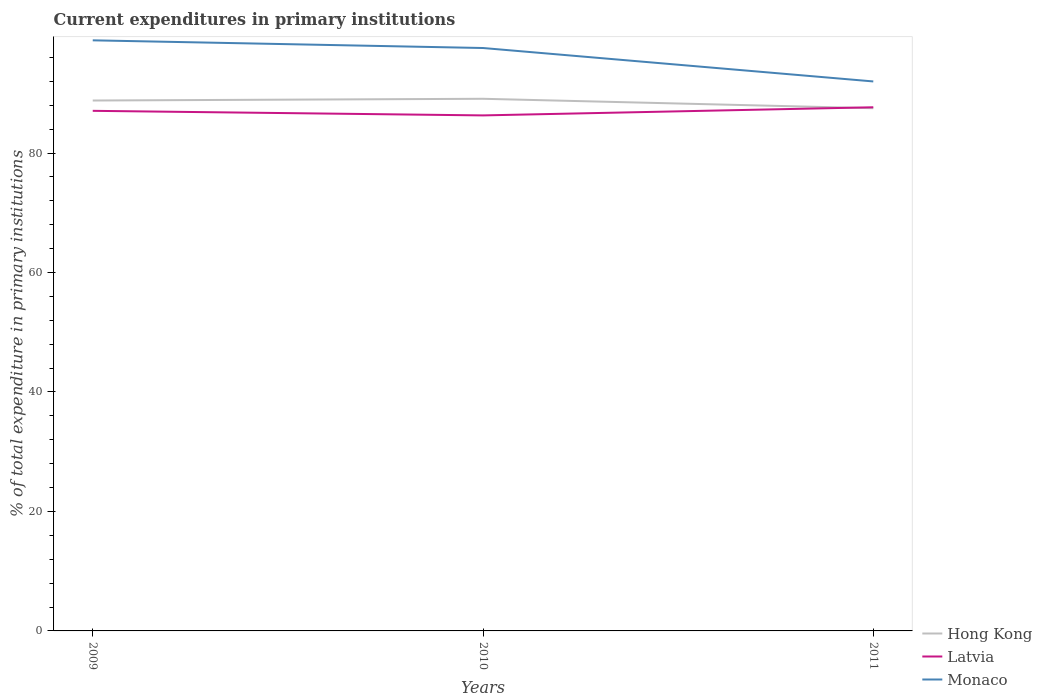How many different coloured lines are there?
Your answer should be compact. 3. Does the line corresponding to Monaco intersect with the line corresponding to Hong Kong?
Provide a short and direct response. No. Across all years, what is the maximum current expenditures in primary institutions in Latvia?
Make the answer very short. 86.3. What is the total current expenditures in primary institutions in Monaco in the graph?
Provide a succinct answer. 5.6. What is the difference between the highest and the second highest current expenditures in primary institutions in Hong Kong?
Ensure brevity in your answer.  1.58. Is the current expenditures in primary institutions in Hong Kong strictly greater than the current expenditures in primary institutions in Latvia over the years?
Make the answer very short. No. How many years are there in the graph?
Provide a short and direct response. 3. What is the difference between two consecutive major ticks on the Y-axis?
Give a very brief answer. 20. Are the values on the major ticks of Y-axis written in scientific E-notation?
Your response must be concise. No. Does the graph contain any zero values?
Make the answer very short. No. Does the graph contain grids?
Keep it short and to the point. No. How are the legend labels stacked?
Keep it short and to the point. Vertical. What is the title of the graph?
Ensure brevity in your answer.  Current expenditures in primary institutions. What is the label or title of the Y-axis?
Provide a succinct answer. % of total expenditure in primary institutions. What is the % of total expenditure in primary institutions of Hong Kong in 2009?
Offer a very short reply. 88.79. What is the % of total expenditure in primary institutions in Latvia in 2009?
Your response must be concise. 87.06. What is the % of total expenditure in primary institutions in Monaco in 2009?
Provide a short and direct response. 98.87. What is the % of total expenditure in primary institutions in Hong Kong in 2010?
Offer a terse response. 89.08. What is the % of total expenditure in primary institutions of Latvia in 2010?
Ensure brevity in your answer.  86.3. What is the % of total expenditure in primary institutions of Monaco in 2010?
Offer a very short reply. 97.58. What is the % of total expenditure in primary institutions in Hong Kong in 2011?
Ensure brevity in your answer.  87.5. What is the % of total expenditure in primary institutions of Latvia in 2011?
Your answer should be very brief. 87.66. What is the % of total expenditure in primary institutions of Monaco in 2011?
Ensure brevity in your answer.  91.98. Across all years, what is the maximum % of total expenditure in primary institutions in Hong Kong?
Offer a terse response. 89.08. Across all years, what is the maximum % of total expenditure in primary institutions in Latvia?
Keep it short and to the point. 87.66. Across all years, what is the maximum % of total expenditure in primary institutions of Monaco?
Your answer should be compact. 98.87. Across all years, what is the minimum % of total expenditure in primary institutions of Hong Kong?
Keep it short and to the point. 87.5. Across all years, what is the minimum % of total expenditure in primary institutions in Latvia?
Offer a terse response. 86.3. Across all years, what is the minimum % of total expenditure in primary institutions of Monaco?
Your answer should be very brief. 91.98. What is the total % of total expenditure in primary institutions of Hong Kong in the graph?
Your response must be concise. 265.37. What is the total % of total expenditure in primary institutions in Latvia in the graph?
Your answer should be very brief. 261.02. What is the total % of total expenditure in primary institutions of Monaco in the graph?
Your answer should be compact. 288.43. What is the difference between the % of total expenditure in primary institutions of Hong Kong in 2009 and that in 2010?
Ensure brevity in your answer.  -0.29. What is the difference between the % of total expenditure in primary institutions of Latvia in 2009 and that in 2010?
Your answer should be very brief. 0.77. What is the difference between the % of total expenditure in primary institutions in Monaco in 2009 and that in 2010?
Offer a terse response. 1.29. What is the difference between the % of total expenditure in primary institutions in Hong Kong in 2009 and that in 2011?
Make the answer very short. 1.29. What is the difference between the % of total expenditure in primary institutions of Latvia in 2009 and that in 2011?
Provide a succinct answer. -0.6. What is the difference between the % of total expenditure in primary institutions in Monaco in 2009 and that in 2011?
Offer a very short reply. 6.88. What is the difference between the % of total expenditure in primary institutions in Hong Kong in 2010 and that in 2011?
Keep it short and to the point. 1.58. What is the difference between the % of total expenditure in primary institutions in Latvia in 2010 and that in 2011?
Make the answer very short. -1.36. What is the difference between the % of total expenditure in primary institutions of Monaco in 2010 and that in 2011?
Give a very brief answer. 5.6. What is the difference between the % of total expenditure in primary institutions in Hong Kong in 2009 and the % of total expenditure in primary institutions in Latvia in 2010?
Offer a very short reply. 2.49. What is the difference between the % of total expenditure in primary institutions in Hong Kong in 2009 and the % of total expenditure in primary institutions in Monaco in 2010?
Your answer should be very brief. -8.79. What is the difference between the % of total expenditure in primary institutions in Latvia in 2009 and the % of total expenditure in primary institutions in Monaco in 2010?
Your answer should be compact. -10.52. What is the difference between the % of total expenditure in primary institutions in Hong Kong in 2009 and the % of total expenditure in primary institutions in Latvia in 2011?
Keep it short and to the point. 1.13. What is the difference between the % of total expenditure in primary institutions in Hong Kong in 2009 and the % of total expenditure in primary institutions in Monaco in 2011?
Keep it short and to the point. -3.19. What is the difference between the % of total expenditure in primary institutions of Latvia in 2009 and the % of total expenditure in primary institutions of Monaco in 2011?
Your answer should be very brief. -4.92. What is the difference between the % of total expenditure in primary institutions of Hong Kong in 2010 and the % of total expenditure in primary institutions of Latvia in 2011?
Provide a short and direct response. 1.42. What is the difference between the % of total expenditure in primary institutions of Hong Kong in 2010 and the % of total expenditure in primary institutions of Monaco in 2011?
Offer a very short reply. -2.9. What is the difference between the % of total expenditure in primary institutions in Latvia in 2010 and the % of total expenditure in primary institutions in Monaco in 2011?
Provide a succinct answer. -5.69. What is the average % of total expenditure in primary institutions of Hong Kong per year?
Offer a terse response. 88.46. What is the average % of total expenditure in primary institutions in Latvia per year?
Your answer should be compact. 87.01. What is the average % of total expenditure in primary institutions in Monaco per year?
Offer a terse response. 96.14. In the year 2009, what is the difference between the % of total expenditure in primary institutions in Hong Kong and % of total expenditure in primary institutions in Latvia?
Your answer should be very brief. 1.73. In the year 2009, what is the difference between the % of total expenditure in primary institutions in Hong Kong and % of total expenditure in primary institutions in Monaco?
Your answer should be very brief. -10.08. In the year 2009, what is the difference between the % of total expenditure in primary institutions of Latvia and % of total expenditure in primary institutions of Monaco?
Offer a very short reply. -11.8. In the year 2010, what is the difference between the % of total expenditure in primary institutions in Hong Kong and % of total expenditure in primary institutions in Latvia?
Give a very brief answer. 2.78. In the year 2010, what is the difference between the % of total expenditure in primary institutions of Hong Kong and % of total expenditure in primary institutions of Monaco?
Provide a short and direct response. -8.5. In the year 2010, what is the difference between the % of total expenditure in primary institutions in Latvia and % of total expenditure in primary institutions in Monaco?
Give a very brief answer. -11.28. In the year 2011, what is the difference between the % of total expenditure in primary institutions in Hong Kong and % of total expenditure in primary institutions in Latvia?
Your answer should be compact. -0.16. In the year 2011, what is the difference between the % of total expenditure in primary institutions of Hong Kong and % of total expenditure in primary institutions of Monaco?
Your answer should be compact. -4.48. In the year 2011, what is the difference between the % of total expenditure in primary institutions of Latvia and % of total expenditure in primary institutions of Monaco?
Your answer should be compact. -4.32. What is the ratio of the % of total expenditure in primary institutions in Hong Kong in 2009 to that in 2010?
Your answer should be compact. 1. What is the ratio of the % of total expenditure in primary institutions in Latvia in 2009 to that in 2010?
Provide a short and direct response. 1.01. What is the ratio of the % of total expenditure in primary institutions in Monaco in 2009 to that in 2010?
Make the answer very short. 1.01. What is the ratio of the % of total expenditure in primary institutions in Hong Kong in 2009 to that in 2011?
Ensure brevity in your answer.  1.01. What is the ratio of the % of total expenditure in primary institutions of Latvia in 2009 to that in 2011?
Your answer should be very brief. 0.99. What is the ratio of the % of total expenditure in primary institutions of Monaco in 2009 to that in 2011?
Your answer should be compact. 1.07. What is the ratio of the % of total expenditure in primary institutions of Latvia in 2010 to that in 2011?
Give a very brief answer. 0.98. What is the ratio of the % of total expenditure in primary institutions in Monaco in 2010 to that in 2011?
Ensure brevity in your answer.  1.06. What is the difference between the highest and the second highest % of total expenditure in primary institutions of Hong Kong?
Provide a succinct answer. 0.29. What is the difference between the highest and the second highest % of total expenditure in primary institutions in Latvia?
Provide a succinct answer. 0.6. What is the difference between the highest and the second highest % of total expenditure in primary institutions in Monaco?
Your response must be concise. 1.29. What is the difference between the highest and the lowest % of total expenditure in primary institutions of Hong Kong?
Ensure brevity in your answer.  1.58. What is the difference between the highest and the lowest % of total expenditure in primary institutions in Latvia?
Your response must be concise. 1.36. What is the difference between the highest and the lowest % of total expenditure in primary institutions of Monaco?
Ensure brevity in your answer.  6.88. 